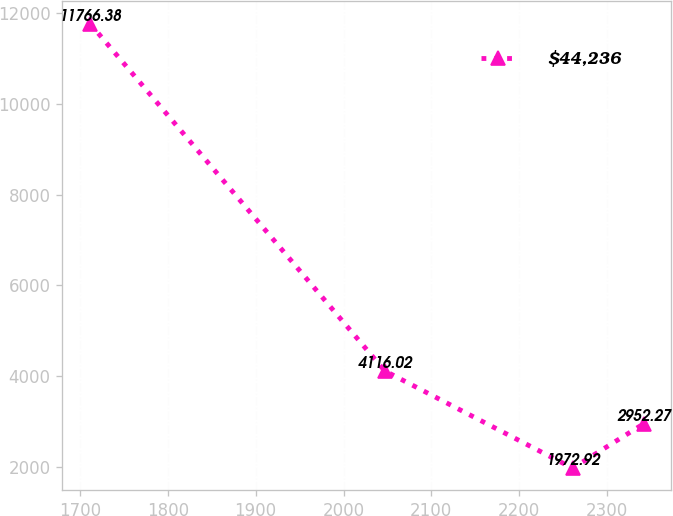<chart> <loc_0><loc_0><loc_500><loc_500><line_chart><ecel><fcel>$44,236<nl><fcel>1711.36<fcel>11766.4<nl><fcel>2046.95<fcel>4116.02<nl><fcel>2260.82<fcel>1972.92<nl><fcel>2341.83<fcel>2952.27<nl></chart> 